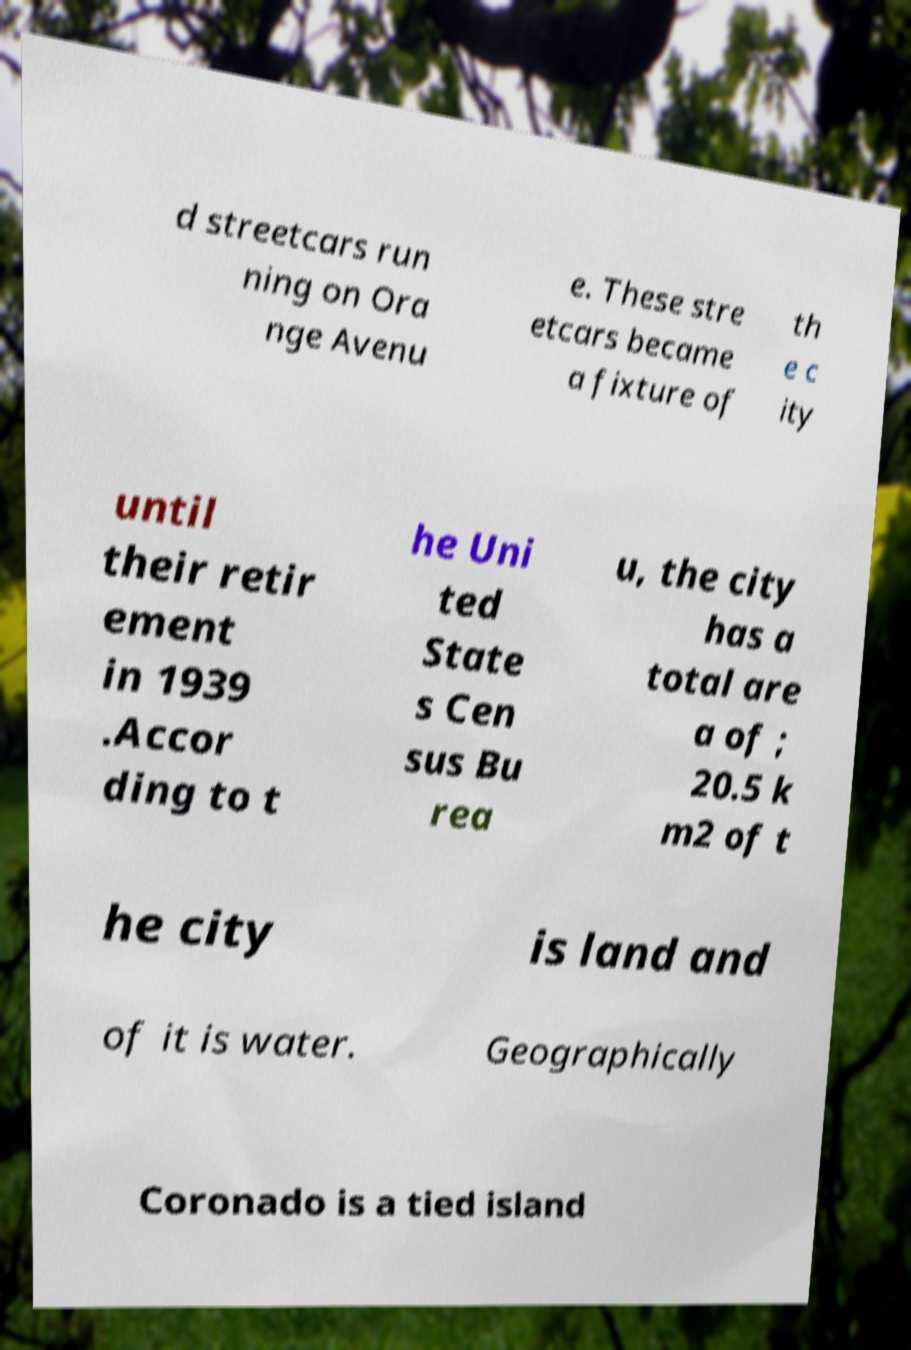What messages or text are displayed in this image? I need them in a readable, typed format. d streetcars run ning on Ora nge Avenu e. These stre etcars became a fixture of th e c ity until their retir ement in 1939 .Accor ding to t he Uni ted State s Cen sus Bu rea u, the city has a total are a of ; 20.5 k m2 of t he city is land and of it is water. Geographically Coronado is a tied island 